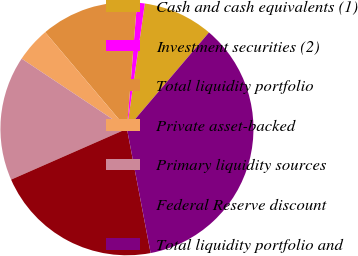Convert chart to OTSL. <chart><loc_0><loc_0><loc_500><loc_500><pie_chart><fcel>Cash and cash equivalents (1)<fcel>Investment securities (2)<fcel>Total liquidity portfolio<fcel>Private asset-backed<fcel>Primary liquidity sources<fcel>Federal Reserve discount<fcel>Total liquidity portfolio and<nl><fcel>8.97%<fcel>0.99%<fcel>12.45%<fcel>4.47%<fcel>15.93%<fcel>21.41%<fcel>35.78%<nl></chart> 